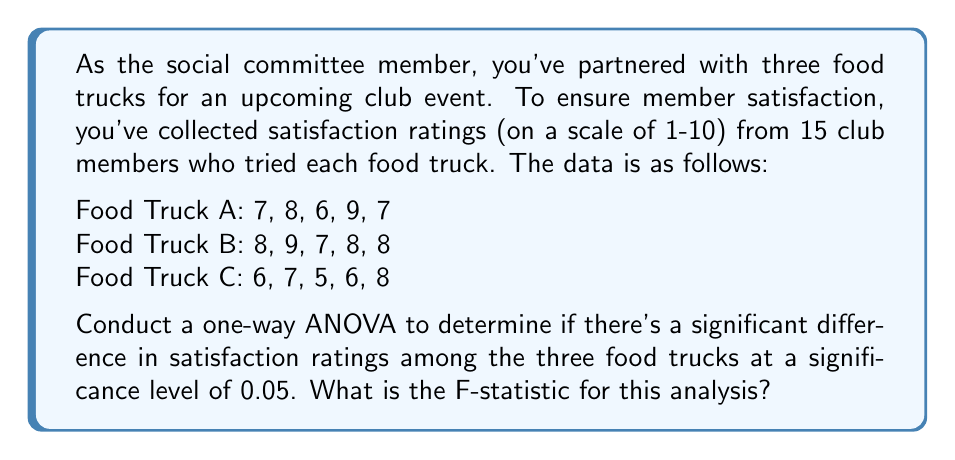Teach me how to tackle this problem. Let's perform a one-way ANOVA step-by-step:

1. Calculate the mean for each group:
   $\bar{X}_A = 7.4$, $\bar{X}_B = 8$, $\bar{X}_C = 6.4$

2. Calculate the grand mean:
   $\bar{X} = \frac{7.4 + 8 + 6.4}{3} = 7.267$

3. Calculate SST (Total Sum of Squares):
   $$SST = \sum_{i=1}^{3}\sum_{j=1}^{5}(X_{ij} - \bar{X})^2 = 28.933$$

4. Calculate SSB (Between-group Sum of Squares):
   $$SSB = 5[(7.4 - 7.267)^2 + (8 - 7.267)^2 + (6.4 - 7.267)^2] = 8.133$$

5. Calculate SSW (Within-group Sum of Squares):
   $$SSW = SST - SSB = 28.933 - 8.133 = 20.8$$

6. Calculate degrees of freedom:
   $df_{between} = k - 1 = 3 - 1 = 2$ (where k is the number of groups)
   $df_{within} = N - k = 15 - 3 = 12$ (where N is the total number of observations)

7. Calculate Mean Square Between (MSB) and Mean Square Within (MSW):
   $$MSB = \frac{SSB}{df_{between}} = \frac{8.133}{2} = 4.0665$$
   $$MSW = \frac{SSW}{df_{within}} = \frac{20.8}{12} = 1.7333$$

8. Calculate the F-statistic:
   $$F = \frac{MSB}{MSW} = \frac{4.0665}{1.7333} = 2.3461$$

Therefore, the F-statistic for this analysis is 2.3461.
Answer: 2.3461 